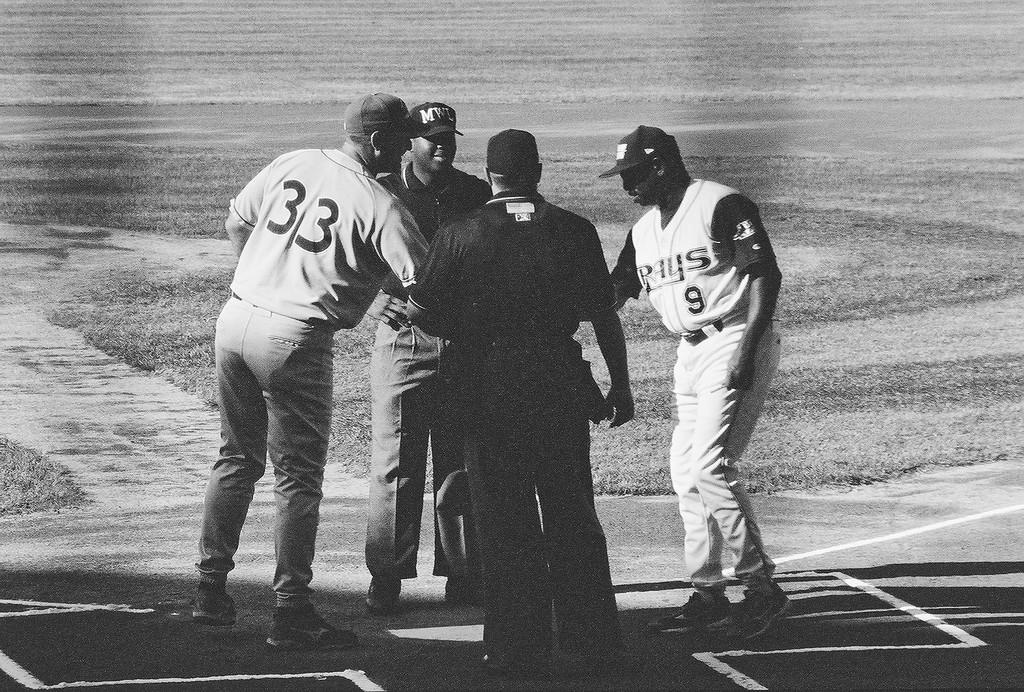<image>
Share a concise interpretation of the image provided. A players for the Rays wears a jersey with the number 9 